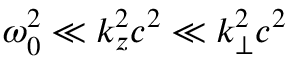Convert formula to latex. <formula><loc_0><loc_0><loc_500><loc_500>\omega _ { 0 } ^ { 2 } \ll k _ { z } ^ { 2 } c ^ { 2 } \ll k _ { \perp } ^ { 2 } c ^ { 2 }</formula> 